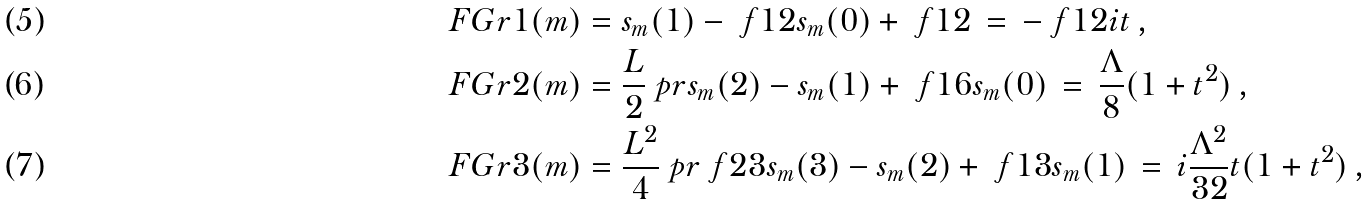<formula> <loc_0><loc_0><loc_500><loc_500>\ F G r 1 ( m ) & = s _ { m } ( 1 ) - \ f 1 2 s _ { m } ( 0 ) + \ f 1 2 \, = \, - \ f 1 2 i t \, , \\ \ F G r 2 ( m ) & = \frac { L } { 2 } \ p r { s _ { m } ( 2 ) - s _ { m } ( 1 ) + \ f 1 6 s _ { m } ( 0 ) } \, = \, \frac { \Lambda } { 8 } ( 1 + t ^ { 2 } ) \, , \\ \ F G r 3 ( m ) & = \frac { L ^ { 2 } } { 4 } \ p r { \ f 2 3 s _ { m } ( 3 ) - s _ { m } ( 2 ) + \ f 1 3 s _ { m } ( 1 ) } \, = \, i \frac { \Lambda ^ { 2 } } { 3 2 } t ( 1 + t ^ { 2 } ) \, ,</formula> 